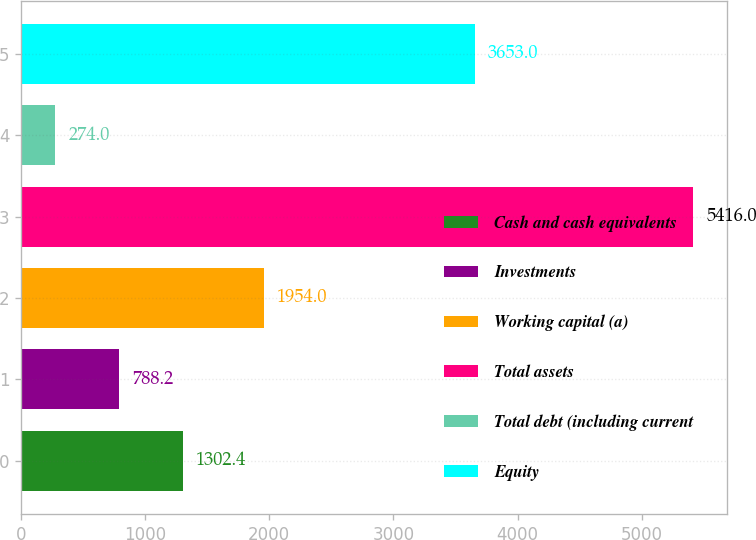Convert chart. <chart><loc_0><loc_0><loc_500><loc_500><bar_chart><fcel>Cash and cash equivalents<fcel>Investments<fcel>Working capital (a)<fcel>Total assets<fcel>Total debt (including current<fcel>Equity<nl><fcel>1302.4<fcel>788.2<fcel>1954<fcel>5416<fcel>274<fcel>3653<nl></chart> 